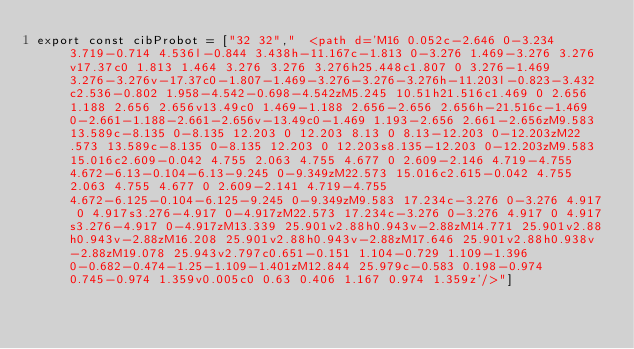Convert code to text. <code><loc_0><loc_0><loc_500><loc_500><_JavaScript_>export const cibProbot = ["32 32","  <path d='M16 0.052c-2.646 0-3.234 3.719-0.714 4.536l-0.844 3.438h-11.167c-1.813 0-3.276 1.469-3.276 3.276v17.37c0 1.813 1.464 3.276 3.276 3.276h25.448c1.807 0 3.276-1.469 3.276-3.276v-17.37c0-1.807-1.469-3.276-3.276-3.276h-11.203l-0.823-3.432c2.536-0.802 1.958-4.542-0.698-4.542zM5.245 10.51h21.516c1.469 0 2.656 1.188 2.656 2.656v13.49c0 1.469-1.188 2.656-2.656 2.656h-21.516c-1.469 0-2.661-1.188-2.661-2.656v-13.49c0-1.469 1.193-2.656 2.661-2.656zM9.583 13.589c-8.135 0-8.135 12.203 0 12.203 8.13 0 8.13-12.203 0-12.203zM22.573 13.589c-8.135 0-8.135 12.203 0 12.203s8.135-12.203 0-12.203zM9.583 15.016c2.609-0.042 4.755 2.063 4.755 4.677 0 2.609-2.146 4.719-4.755 4.672-6.13-0.104-6.13-9.245 0-9.349zM22.573 15.016c2.615-0.042 4.755 2.063 4.755 4.677 0 2.609-2.141 4.719-4.755 4.672-6.125-0.104-6.125-9.245 0-9.349zM9.583 17.234c-3.276 0-3.276 4.917 0 4.917s3.276-4.917 0-4.917zM22.573 17.234c-3.276 0-3.276 4.917 0 4.917s3.276-4.917 0-4.917zM13.339 25.901v2.88h0.943v-2.88zM14.771 25.901v2.88h0.943v-2.88zM16.208 25.901v2.88h0.943v-2.88zM17.646 25.901v2.88h0.938v-2.88zM19.078 25.943v2.797c0.651-0.151 1.104-0.729 1.109-1.396 0-0.682-0.474-1.25-1.109-1.401zM12.844 25.979c-0.583 0.198-0.974 0.745-0.974 1.359v0.005c0 0.63 0.406 1.167 0.974 1.359z'/>"]</code> 